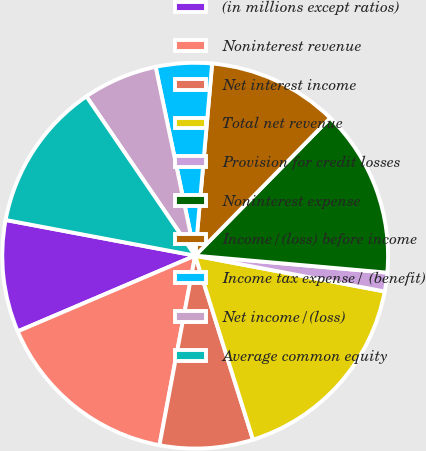Convert chart. <chart><loc_0><loc_0><loc_500><loc_500><pie_chart><fcel>(in millions except ratios)<fcel>Noninterest revenue<fcel>Net interest income<fcel>Total net revenue<fcel>Provision for credit losses<fcel>Noninterest expense<fcel>Income/(loss) before income<fcel>Income tax expense/ (benefit)<fcel>Net income/(loss)<fcel>Average common equity<nl><fcel>9.38%<fcel>15.62%<fcel>7.81%<fcel>17.18%<fcel>1.57%<fcel>14.06%<fcel>10.94%<fcel>4.69%<fcel>6.25%<fcel>12.5%<nl></chart> 